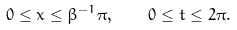Convert formula to latex. <formula><loc_0><loc_0><loc_500><loc_500>0 \leq x \leq \beta ^ { - 1 } \pi , \quad 0 \leq t \leq 2 \pi .</formula> 